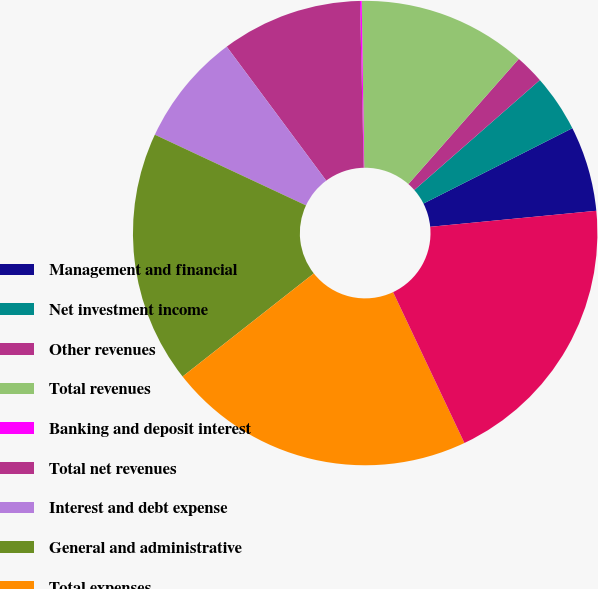Convert chart. <chart><loc_0><loc_0><loc_500><loc_500><pie_chart><fcel>Management and financial<fcel>Net investment income<fcel>Other revenues<fcel>Total revenues<fcel>Banking and deposit interest<fcel>Total net revenues<fcel>Interest and debt expense<fcel>General and administrative<fcel>Total expenses<fcel>Pretax loss before equity in<nl><fcel>5.93%<fcel>3.99%<fcel>2.05%<fcel>11.74%<fcel>0.12%<fcel>9.81%<fcel>7.87%<fcel>17.56%<fcel>21.43%<fcel>19.5%<nl></chart> 